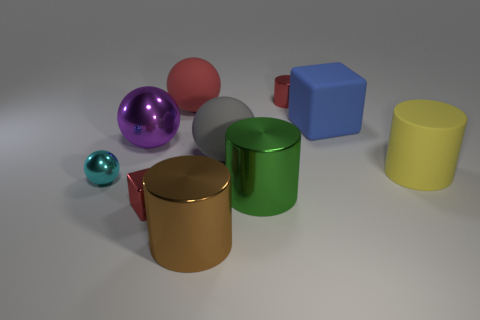There is a green thing that is the same size as the red matte thing; what material is it?
Keep it short and to the point. Metal. The tiny object that is to the right of the purple thing and in front of the large blue rubber thing is made of what material?
Offer a terse response. Metal. Are there any tiny blue objects?
Your response must be concise. No. Is the color of the small metallic cylinder the same as the tiny object that is in front of the cyan object?
Give a very brief answer. Yes. What is the material of the cylinder that is the same color as the shiny cube?
Give a very brief answer. Metal. What is the shape of the small red shiny thing that is in front of the small red metallic thing behind the big metal cylinder on the right side of the gray object?
Offer a very short reply. Cube. What is the shape of the yellow rubber thing?
Offer a terse response. Cylinder. What color is the cube on the left side of the brown object?
Ensure brevity in your answer.  Red. Is the size of the red metallic thing that is on the left side of the brown cylinder the same as the large blue matte thing?
Provide a short and direct response. No. What is the size of the red metallic thing that is the same shape as the large brown thing?
Provide a short and direct response. Small. 